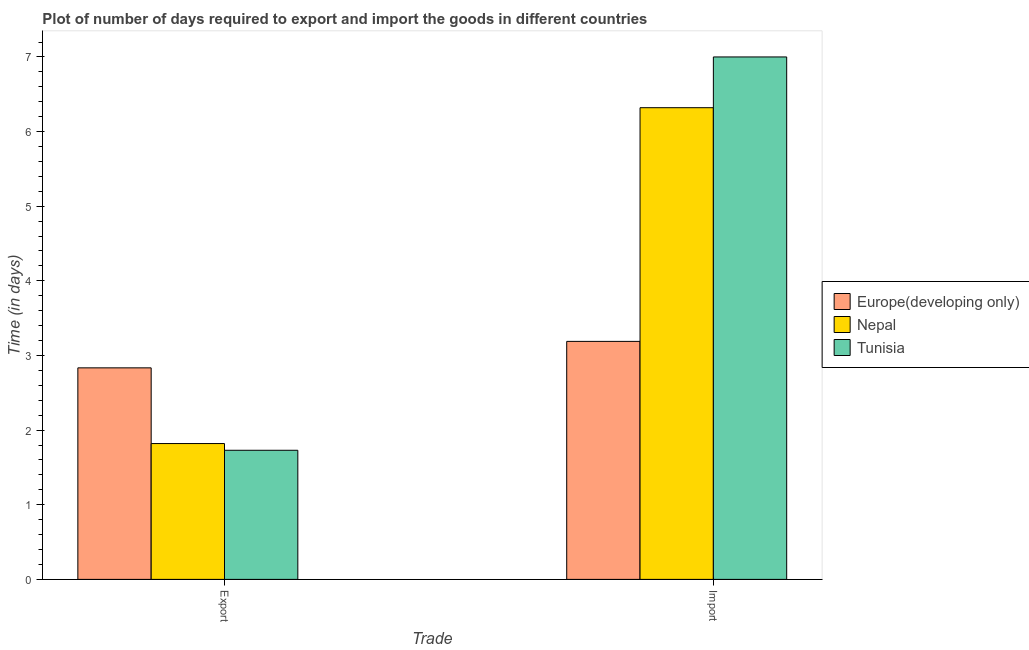How many groups of bars are there?
Your answer should be compact. 2. How many bars are there on the 2nd tick from the left?
Offer a very short reply. 3. What is the label of the 1st group of bars from the left?
Offer a very short reply. Export. What is the time required to import in Nepal?
Keep it short and to the point. 6.32. Across all countries, what is the maximum time required to export?
Provide a succinct answer. 2.83. Across all countries, what is the minimum time required to import?
Provide a succinct answer. 3.19. In which country was the time required to import maximum?
Ensure brevity in your answer.  Tunisia. In which country was the time required to export minimum?
Offer a very short reply. Tunisia. What is the total time required to export in the graph?
Provide a short and direct response. 6.38. What is the difference between the time required to import in Europe(developing only) and that in Tunisia?
Provide a short and direct response. -3.81. What is the difference between the time required to import in Nepal and the time required to export in Europe(developing only)?
Ensure brevity in your answer.  3.49. What is the average time required to import per country?
Your answer should be compact. 5.5. What is the difference between the time required to export and time required to import in Tunisia?
Provide a short and direct response. -5.27. What is the ratio of the time required to import in Europe(developing only) to that in Tunisia?
Offer a very short reply. 0.46. What does the 2nd bar from the left in Import represents?
Your answer should be compact. Nepal. What does the 2nd bar from the right in Export represents?
Your response must be concise. Nepal. How many bars are there?
Provide a succinct answer. 6. Are all the bars in the graph horizontal?
Keep it short and to the point. No. How many countries are there in the graph?
Keep it short and to the point. 3. Are the values on the major ticks of Y-axis written in scientific E-notation?
Keep it short and to the point. No. Does the graph contain any zero values?
Provide a short and direct response. No. Does the graph contain grids?
Make the answer very short. No. How are the legend labels stacked?
Your response must be concise. Vertical. What is the title of the graph?
Offer a very short reply. Plot of number of days required to export and import the goods in different countries. Does "Mauritius" appear as one of the legend labels in the graph?
Ensure brevity in your answer.  No. What is the label or title of the X-axis?
Keep it short and to the point. Trade. What is the label or title of the Y-axis?
Your answer should be very brief. Time (in days). What is the Time (in days) in Europe(developing only) in Export?
Provide a short and direct response. 2.83. What is the Time (in days) in Nepal in Export?
Provide a short and direct response. 1.82. What is the Time (in days) of Tunisia in Export?
Offer a very short reply. 1.73. What is the Time (in days) of Europe(developing only) in Import?
Provide a short and direct response. 3.19. What is the Time (in days) in Nepal in Import?
Offer a terse response. 6.32. Across all Trade, what is the maximum Time (in days) of Europe(developing only)?
Your answer should be compact. 3.19. Across all Trade, what is the maximum Time (in days) of Nepal?
Provide a succinct answer. 6.32. Across all Trade, what is the maximum Time (in days) of Tunisia?
Your response must be concise. 7. Across all Trade, what is the minimum Time (in days) in Europe(developing only)?
Keep it short and to the point. 2.83. Across all Trade, what is the minimum Time (in days) of Nepal?
Offer a terse response. 1.82. Across all Trade, what is the minimum Time (in days) of Tunisia?
Offer a very short reply. 1.73. What is the total Time (in days) of Europe(developing only) in the graph?
Provide a short and direct response. 6.02. What is the total Time (in days) in Nepal in the graph?
Keep it short and to the point. 8.14. What is the total Time (in days) in Tunisia in the graph?
Your answer should be very brief. 8.73. What is the difference between the Time (in days) of Europe(developing only) in Export and that in Import?
Ensure brevity in your answer.  -0.35. What is the difference between the Time (in days) of Tunisia in Export and that in Import?
Provide a succinct answer. -5.27. What is the difference between the Time (in days) of Europe(developing only) in Export and the Time (in days) of Nepal in Import?
Your answer should be compact. -3.49. What is the difference between the Time (in days) of Europe(developing only) in Export and the Time (in days) of Tunisia in Import?
Make the answer very short. -4.17. What is the difference between the Time (in days) of Nepal in Export and the Time (in days) of Tunisia in Import?
Your response must be concise. -5.18. What is the average Time (in days) of Europe(developing only) per Trade?
Your answer should be very brief. 3.01. What is the average Time (in days) of Nepal per Trade?
Provide a short and direct response. 4.07. What is the average Time (in days) in Tunisia per Trade?
Your response must be concise. 4.37. What is the difference between the Time (in days) of Europe(developing only) and Time (in days) of Nepal in Export?
Ensure brevity in your answer.  1.01. What is the difference between the Time (in days) in Europe(developing only) and Time (in days) in Tunisia in Export?
Your response must be concise. 1.1. What is the difference between the Time (in days) of Nepal and Time (in days) of Tunisia in Export?
Ensure brevity in your answer.  0.09. What is the difference between the Time (in days) of Europe(developing only) and Time (in days) of Nepal in Import?
Keep it short and to the point. -3.13. What is the difference between the Time (in days) in Europe(developing only) and Time (in days) in Tunisia in Import?
Keep it short and to the point. -3.81. What is the difference between the Time (in days) of Nepal and Time (in days) of Tunisia in Import?
Make the answer very short. -0.68. What is the ratio of the Time (in days) of Europe(developing only) in Export to that in Import?
Offer a terse response. 0.89. What is the ratio of the Time (in days) of Nepal in Export to that in Import?
Offer a very short reply. 0.29. What is the ratio of the Time (in days) in Tunisia in Export to that in Import?
Ensure brevity in your answer.  0.25. What is the difference between the highest and the second highest Time (in days) of Europe(developing only)?
Your answer should be compact. 0.35. What is the difference between the highest and the second highest Time (in days) of Tunisia?
Your answer should be very brief. 5.27. What is the difference between the highest and the lowest Time (in days) in Europe(developing only)?
Make the answer very short. 0.35. What is the difference between the highest and the lowest Time (in days) of Nepal?
Provide a succinct answer. 4.5. What is the difference between the highest and the lowest Time (in days) in Tunisia?
Offer a very short reply. 5.27. 